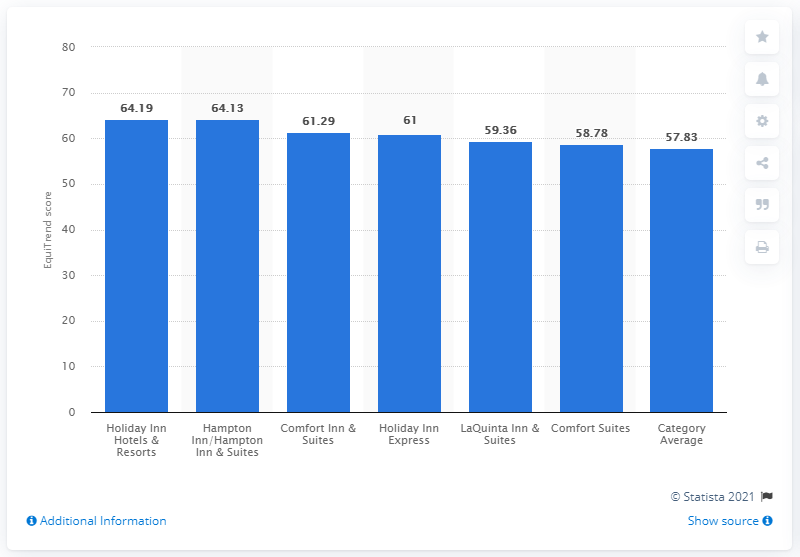Outline some significant characteristics in this image. In 2012, Holiday Inn Hotels & Resorts received an EquiTrend score of 64.19, which indicates a high level of consumer confidence and satisfaction with the brand. 